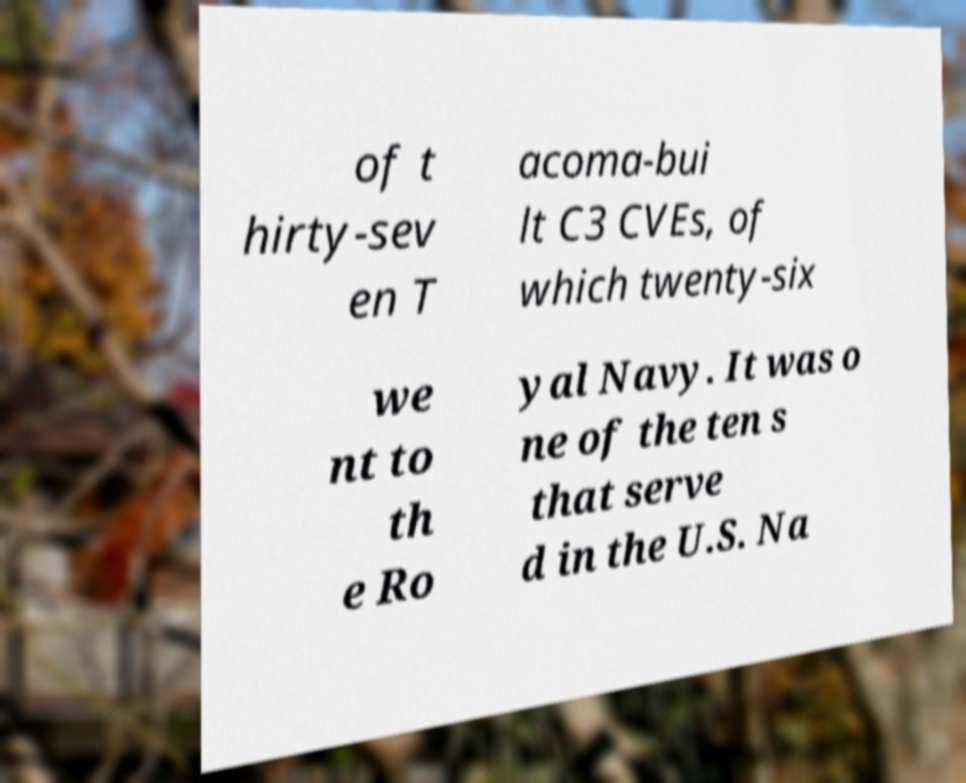What messages or text are displayed in this image? I need them in a readable, typed format. of t hirty-sev en T acoma-bui lt C3 CVEs, of which twenty-six we nt to th e Ro yal Navy. It was o ne of the ten s that serve d in the U.S. Na 